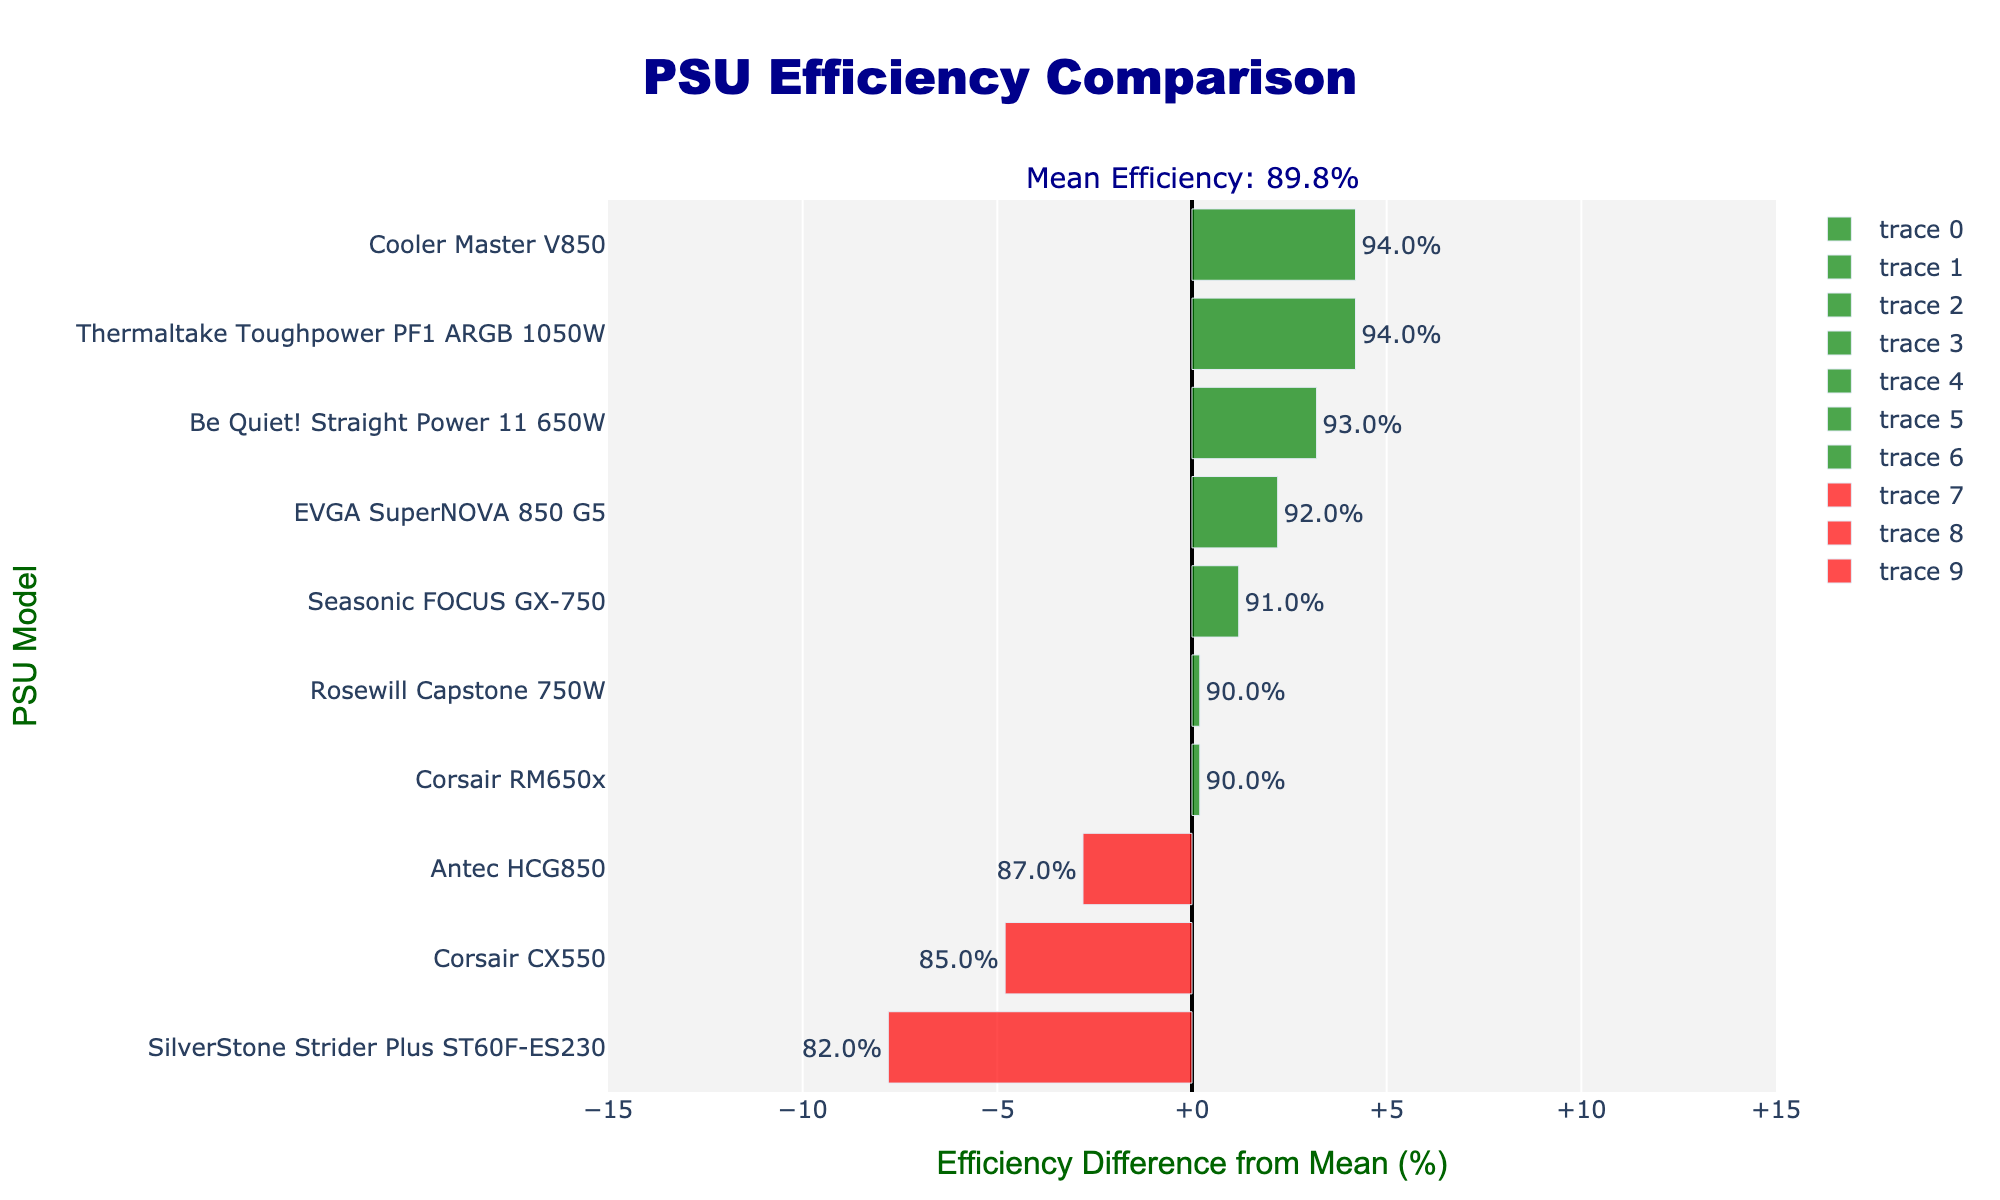Which PSU model has the highest efficiency? The bar representing the Cooler Master V850 and Thermaltake Toughpower PF1 ARGB 1050W are the longest and placed at the rightmost position in the chart, indicating the highest efficiency of 94%.
Answer: Cooler Master V850 and Thermaltake Toughpower PF1 ARGB 1050W Which PSU model has the lowest efficiency? The bar for the SilverStone Strider Plus ST60F-ES230 is the leftmost and shortest bar in the chart, indicating the lowest efficiency of 82%.
Answer: SilverStone Strider Plus ST60F-ES230 How many PSU models have an efficiency higher than the mean efficiency? First, identify the mean efficiency noted in the annotation as 89.8%, then count the number of green bars, which indicate efficiency higher than the mean. In this case, there are 6 such PSUs.
Answer: 6 How many PSU models have an efficiency lower than the mean efficiency? Similarly, identify the mean efficiency and count the number of red bars, which indicate efficiency lower than the mean. Here, there are 4 such PSUs.
Answer: 4 What's the efficiency of the Corsair CX550 PSU model? Locate the bar corresponding to Corsair CX550 and refer to the hover or text label showing its efficiency value, which is 85%.
Answer: 85% Which certification level is most common among the PSUs with efficiency higher than the mean? Identify the certification levels of the green bars (higher than mean) and count their occurrences. "80 Plus Gold" appears with Corsair RM650x, EVGA SuperNOVA 850 G5, Seasonic FOCUS GX-750, and Rosewill Capstone 750W, totalling to 4 instances.
Answer: 80 Plus Gold What is the difference in efficiency between the most efficient and the least efficient PSU models? The most efficient models, Cooler Master V850 and Thermaltake Toughpower PF1 ARGB 1050W, have 94% efficiency, and the least efficient model, SilverStone Strider Plus ST60F-ES230, has 82%. The difference is 94% - 82% = 12%.
Answer: 12% Which PSU model(s) lie exactly at the mean efficiency level? Since the mean efficiency is 89.8%, check the bars which fall exactly at zero on the x-axis. None of the PSU models are exactly at the mean value, meaning none are located at the zero mark.
Answer: None What is the range of efficiencies for PSUs with "80 Plus Gold" certification? Identify "80 Plus Gold" certified PSU bars (Corsair RM650x, EVGA SuperNOVA 850 G5, Seasonic FOCUS GX-750, Rosewill Capstone 750W) and note their efficiencies, which are 90%, 92%, 91%, and 90%. The range is from 90% to 92%.
Answer: 90% to 92% What's the efficiency difference between the Corsair RM650x and the Be Quiet! Straight Power 11 650W? Corsair RM650x has an efficiency of 90% and Be Quiet! Straight Power 11 650W has an efficiency of 93%. The difference is 93% - 90% = 3%.
Answer: 3% 